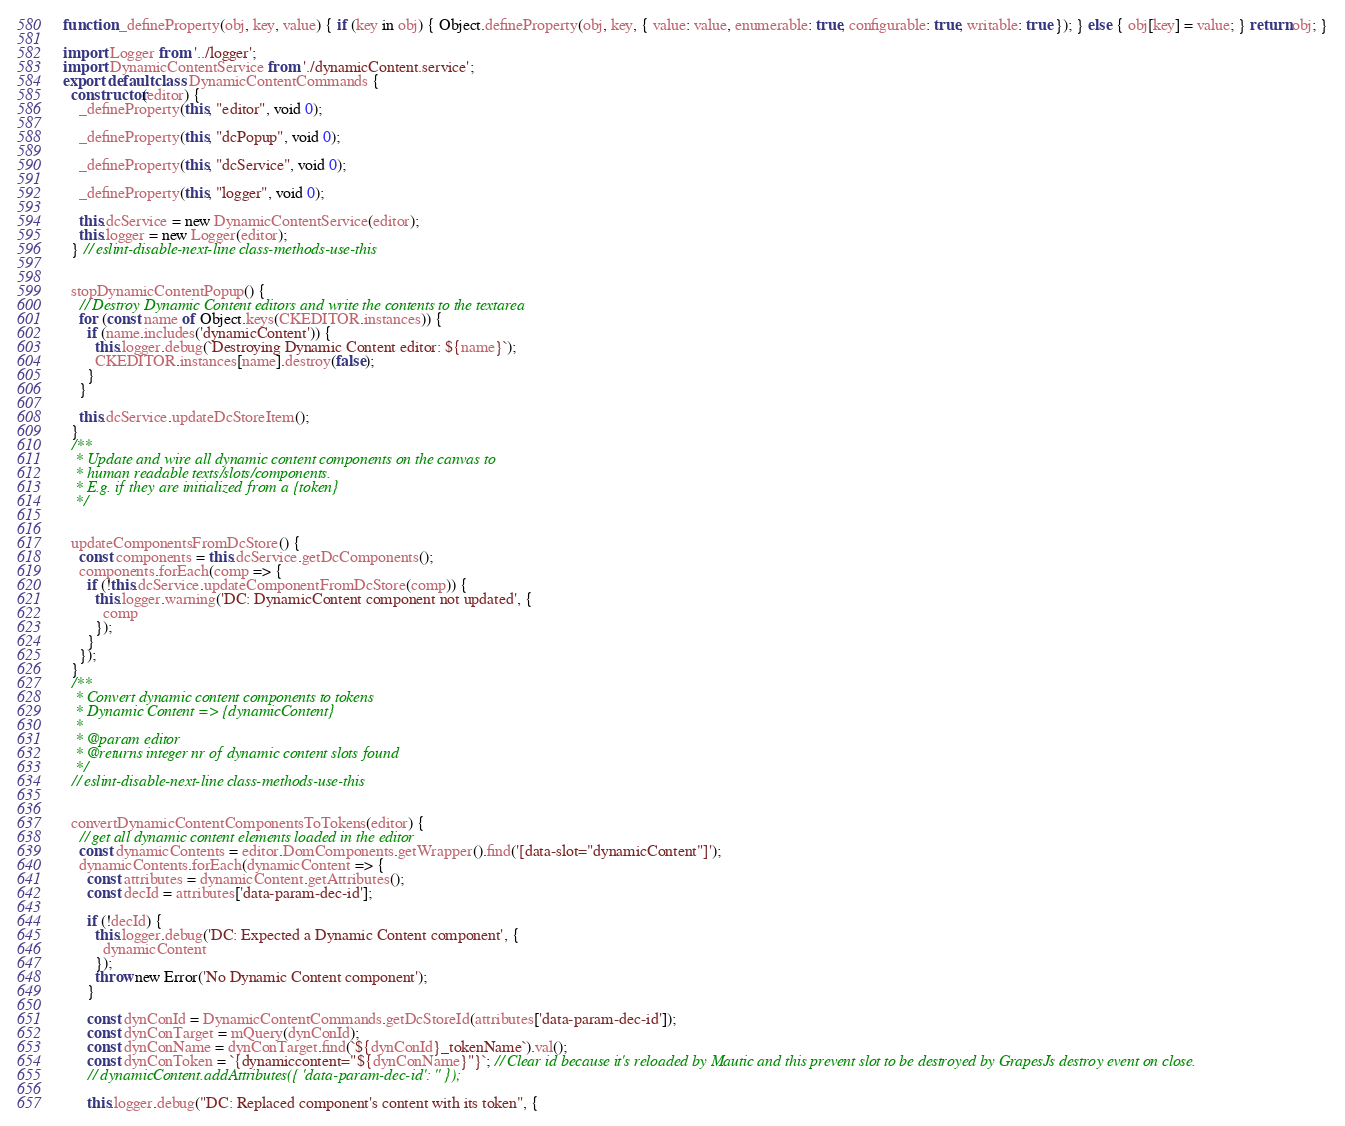<code> <loc_0><loc_0><loc_500><loc_500><_JavaScript_>function _defineProperty(obj, key, value) { if (key in obj) { Object.defineProperty(obj, key, { value: value, enumerable: true, configurable: true, writable: true }); } else { obj[key] = value; } return obj; }

import Logger from '../logger';
import DynamicContentService from './dynamicContent.service';
export default class DynamicContentCommands {
  constructor(editor) {
    _defineProperty(this, "editor", void 0);

    _defineProperty(this, "dcPopup", void 0);

    _defineProperty(this, "dcService", void 0);

    _defineProperty(this, "logger", void 0);

    this.dcService = new DynamicContentService(editor);
    this.logger = new Logger(editor);
  } // eslint-disable-next-line class-methods-use-this


  stopDynamicContentPopup() {
    // Destroy Dynamic Content editors and write the contents to the textarea
    for (const name of Object.keys(CKEDITOR.instances)) {
      if (name.includes('dynamicContent')) {
        this.logger.debug(`Destroying Dynamic Content editor: ${name}`);
        CKEDITOR.instances[name].destroy(false);
      }
    }

    this.dcService.updateDcStoreItem();
  }
  /**
   * Update and wire all dynamic content components on the canvas to
   * human readable texts/slots/components.
   * E.g. if they are initialized from a {token}
   */


  updateComponentsFromDcStore() {
    const components = this.dcService.getDcComponents();
    components.forEach(comp => {
      if (!this.dcService.updateComponentFromDcStore(comp)) {
        this.logger.warning('DC: DynamicContent component not updated', {
          comp
        });
      }
    });
  }
  /**
   * Convert dynamic content components to tokens
   * Dynamic Content => {dynamicContent}
   *
   * @param editor
   * @returns integer nr of dynamic content slots found
   */
  // eslint-disable-next-line class-methods-use-this


  convertDynamicContentComponentsToTokens(editor) {
    // get all dynamic content elements loaded in the editor
    const dynamicContents = editor.DomComponents.getWrapper().find('[data-slot="dynamicContent"]');
    dynamicContents.forEach(dynamicContent => {
      const attributes = dynamicContent.getAttributes();
      const decId = attributes['data-param-dec-id'];

      if (!decId) {
        this.logger.debug('DC: Expected a Dynamic Content component', {
          dynamicContent
        });
        throw new Error('No Dynamic Content component');
      }

      const dynConId = DynamicContentCommands.getDcStoreId(attributes['data-param-dec-id']);
      const dynConTarget = mQuery(dynConId);
      const dynConName = dynConTarget.find(`${dynConId}_tokenName`).val();
      const dynConToken = `{dynamiccontent="${dynConName}"}`; // Clear id because it's reloaded by Mautic and this prevent slot to be destroyed by GrapesJs destroy event on close.
      // dynamicContent.addAttributes({ 'data-param-dec-id': '' });

      this.logger.debug("DC: Replaced component's content with its token", {</code> 